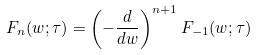Convert formula to latex. <formula><loc_0><loc_0><loc_500><loc_500>F _ { n } ( w ; \tau ) = \left ( - \frac { d } { d w } \right ) ^ { n + 1 } F _ { - 1 } ( w ; \tau )</formula> 